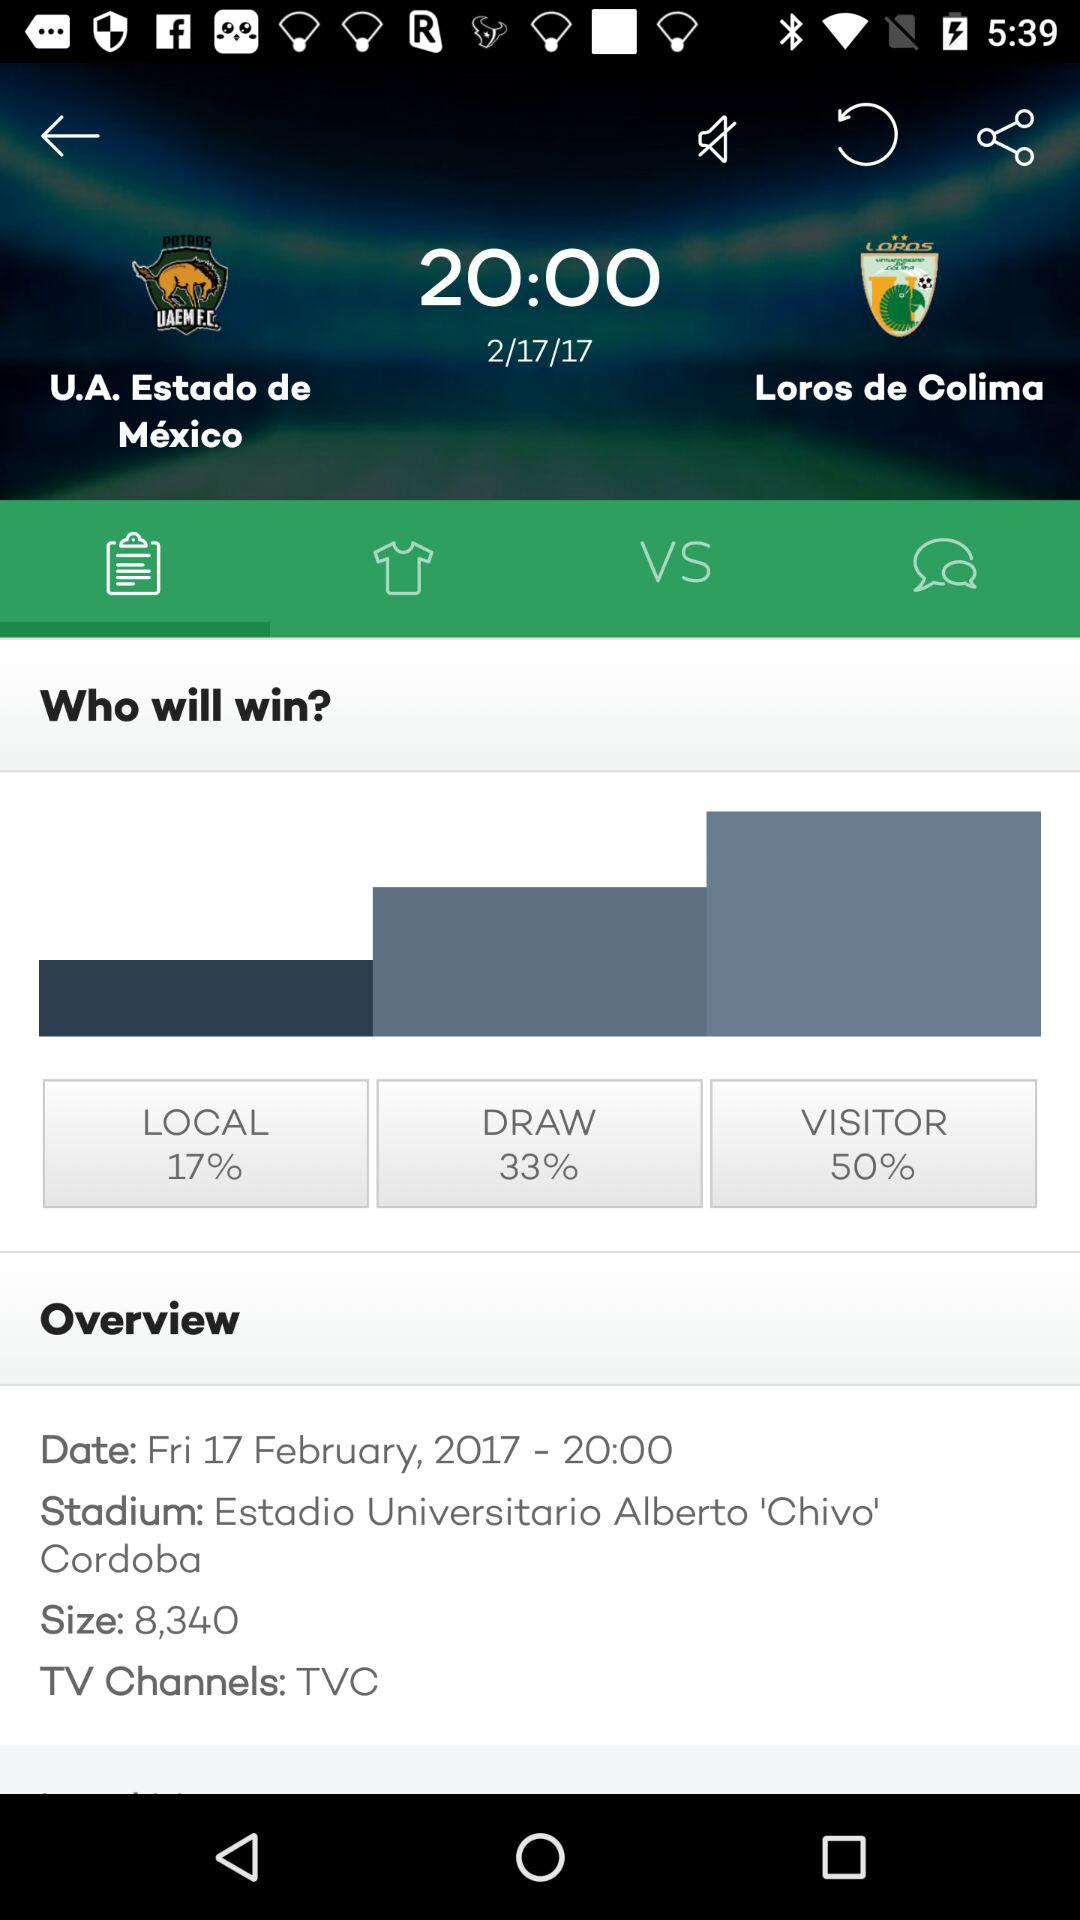What time is the match going to start? The time is 20:00. 